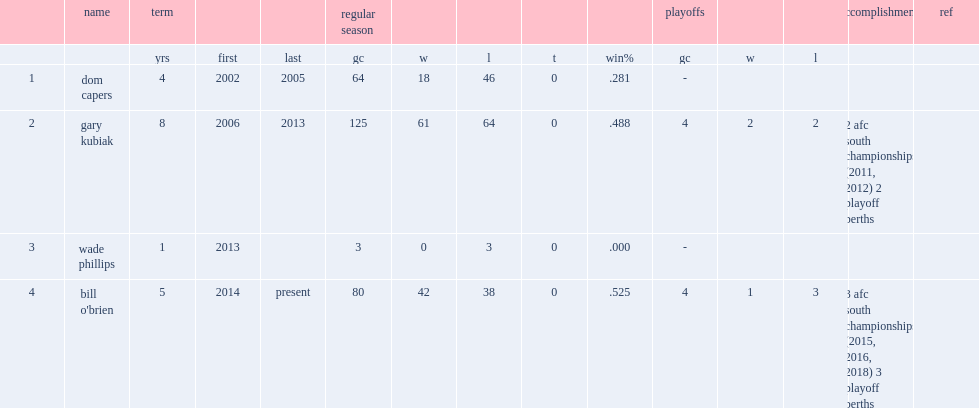Which term was houston texans season the 1st under head coach gary kubiak? 2006.0. 